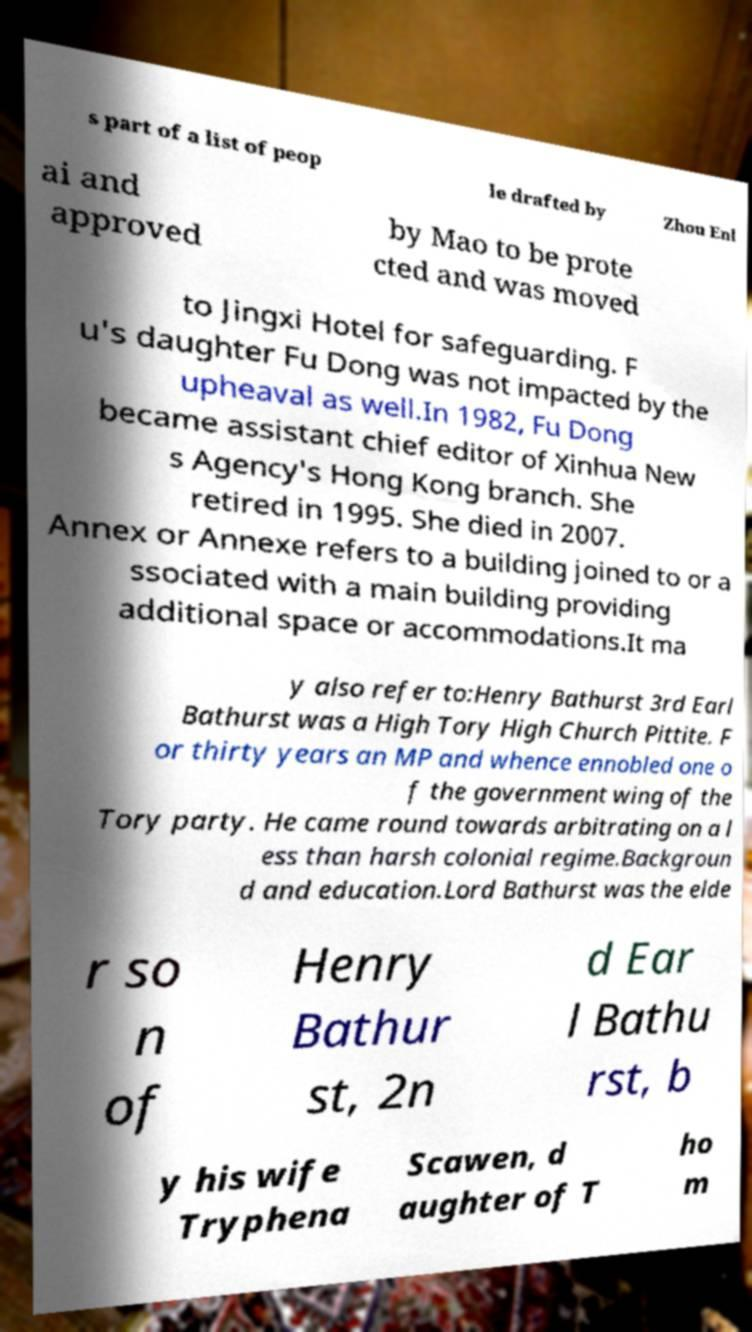Please identify and transcribe the text found in this image. s part of a list of peop le drafted by Zhou Enl ai and approved by Mao to be prote cted and was moved to Jingxi Hotel for safeguarding. F u's daughter Fu Dong was not impacted by the upheaval as well.In 1982, Fu Dong became assistant chief editor of Xinhua New s Agency's Hong Kong branch. She retired in 1995. She died in 2007. Annex or Annexe refers to a building joined to or a ssociated with a main building providing additional space or accommodations.It ma y also refer to:Henry Bathurst 3rd Earl Bathurst was a High Tory High Church Pittite. F or thirty years an MP and whence ennobled one o f the government wing of the Tory party. He came round towards arbitrating on a l ess than harsh colonial regime.Backgroun d and education.Lord Bathurst was the elde r so n of Henry Bathur st, 2n d Ear l Bathu rst, b y his wife Tryphena Scawen, d aughter of T ho m 